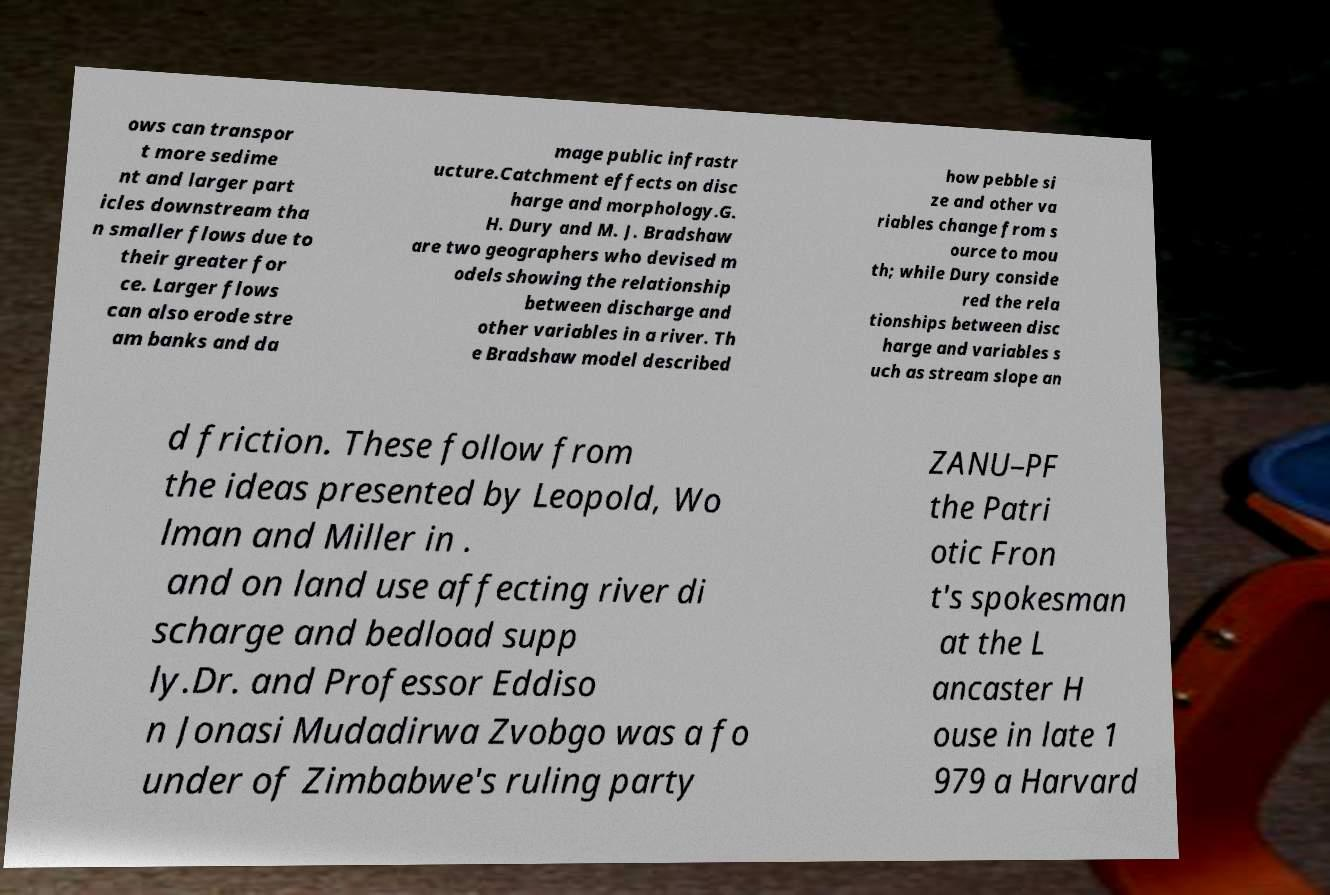For documentation purposes, I need the text within this image transcribed. Could you provide that? ows can transpor t more sedime nt and larger part icles downstream tha n smaller flows due to their greater for ce. Larger flows can also erode stre am banks and da mage public infrastr ucture.Catchment effects on disc harge and morphology.G. H. Dury and M. J. Bradshaw are two geographers who devised m odels showing the relationship between discharge and other variables in a river. Th e Bradshaw model described how pebble si ze and other va riables change from s ource to mou th; while Dury conside red the rela tionships between disc harge and variables s uch as stream slope an d friction. These follow from the ideas presented by Leopold, Wo lman and Miller in . and on land use affecting river di scharge and bedload supp ly.Dr. and Professor Eddiso n Jonasi Mudadirwa Zvobgo was a fo under of Zimbabwe's ruling party ZANU–PF the Patri otic Fron t's spokesman at the L ancaster H ouse in late 1 979 a Harvard 